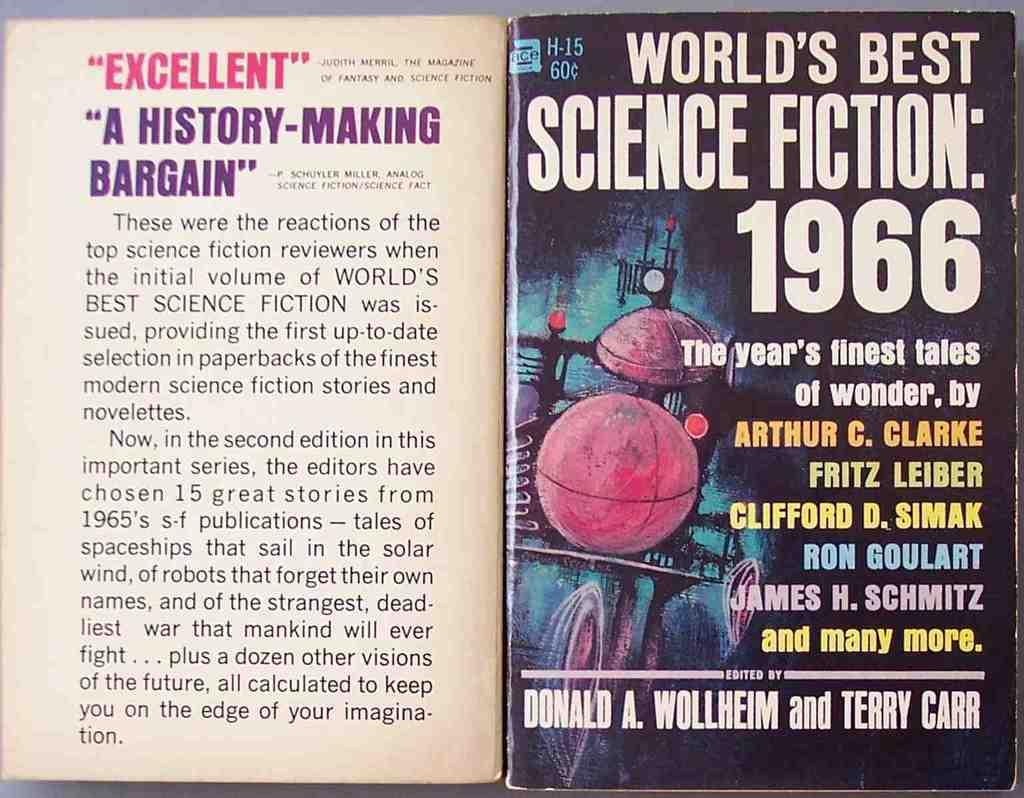<image>
Relay a brief, clear account of the picture shown. Book cover that says "World's Best Science Fiction" from the year 1966. 